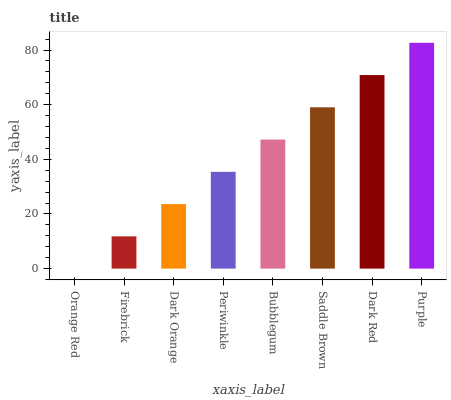Is Orange Red the minimum?
Answer yes or no. Yes. Is Purple the maximum?
Answer yes or no. Yes. Is Firebrick the minimum?
Answer yes or no. No. Is Firebrick the maximum?
Answer yes or no. No. Is Firebrick greater than Orange Red?
Answer yes or no. Yes. Is Orange Red less than Firebrick?
Answer yes or no. Yes. Is Orange Red greater than Firebrick?
Answer yes or no. No. Is Firebrick less than Orange Red?
Answer yes or no. No. Is Bubblegum the high median?
Answer yes or no. Yes. Is Periwinkle the low median?
Answer yes or no. Yes. Is Periwinkle the high median?
Answer yes or no. No. Is Saddle Brown the low median?
Answer yes or no. No. 